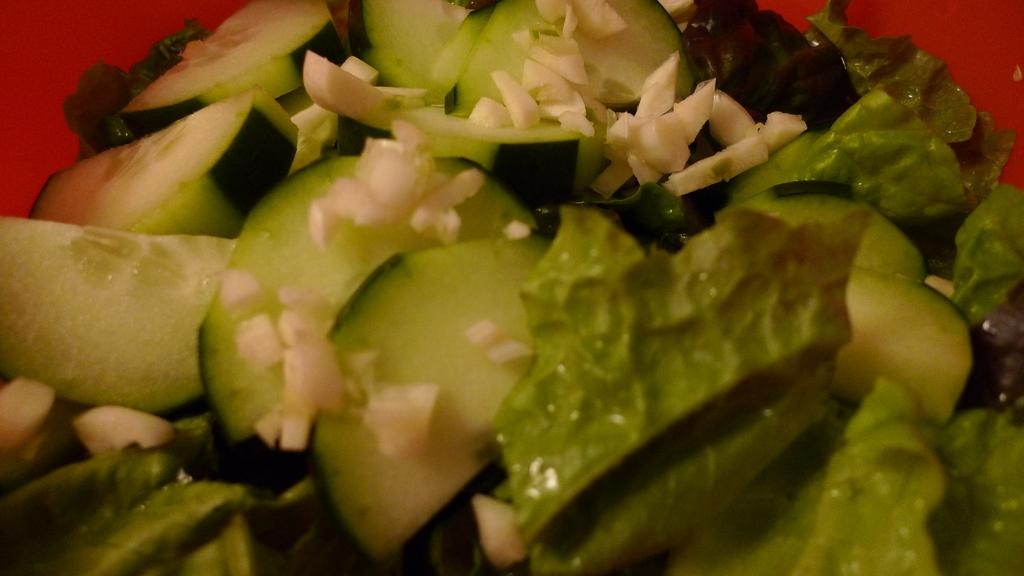What type of items can be seen in the image? There are eatable items placed in the image. What mark can be seen on the eatable items in the image? There is no mention of any mark on the eatable items in the image. 